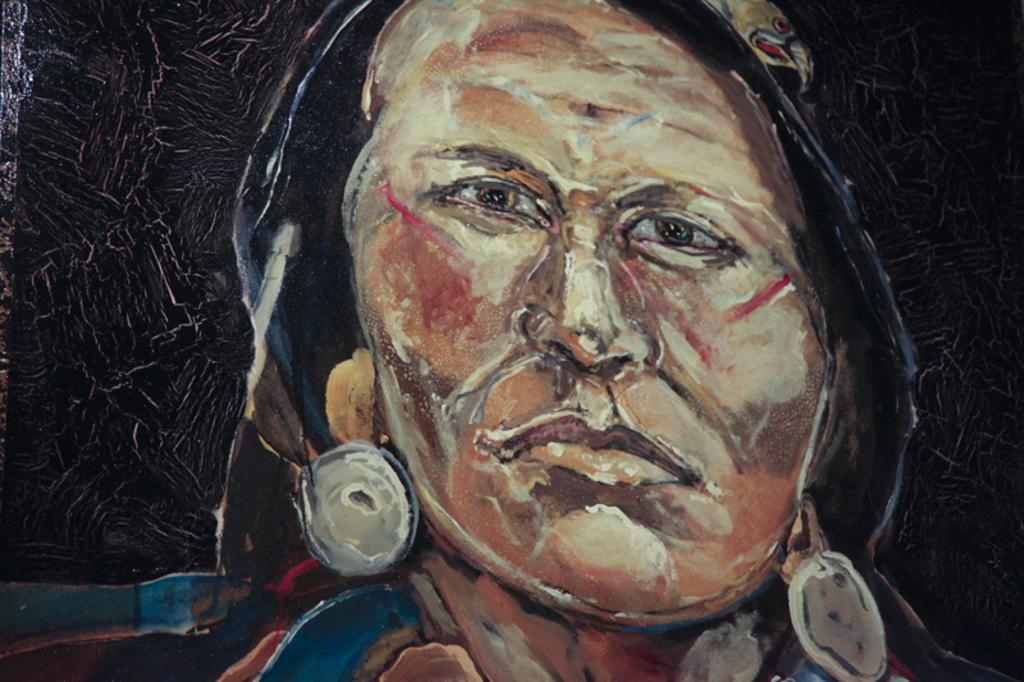What is the main subject of the painting in the image? There is a painting of a person in the image. How many times does the person in the painting kiss someone else in the image? There is no indication of any kissing in the image, as it only features a painting of a person. 